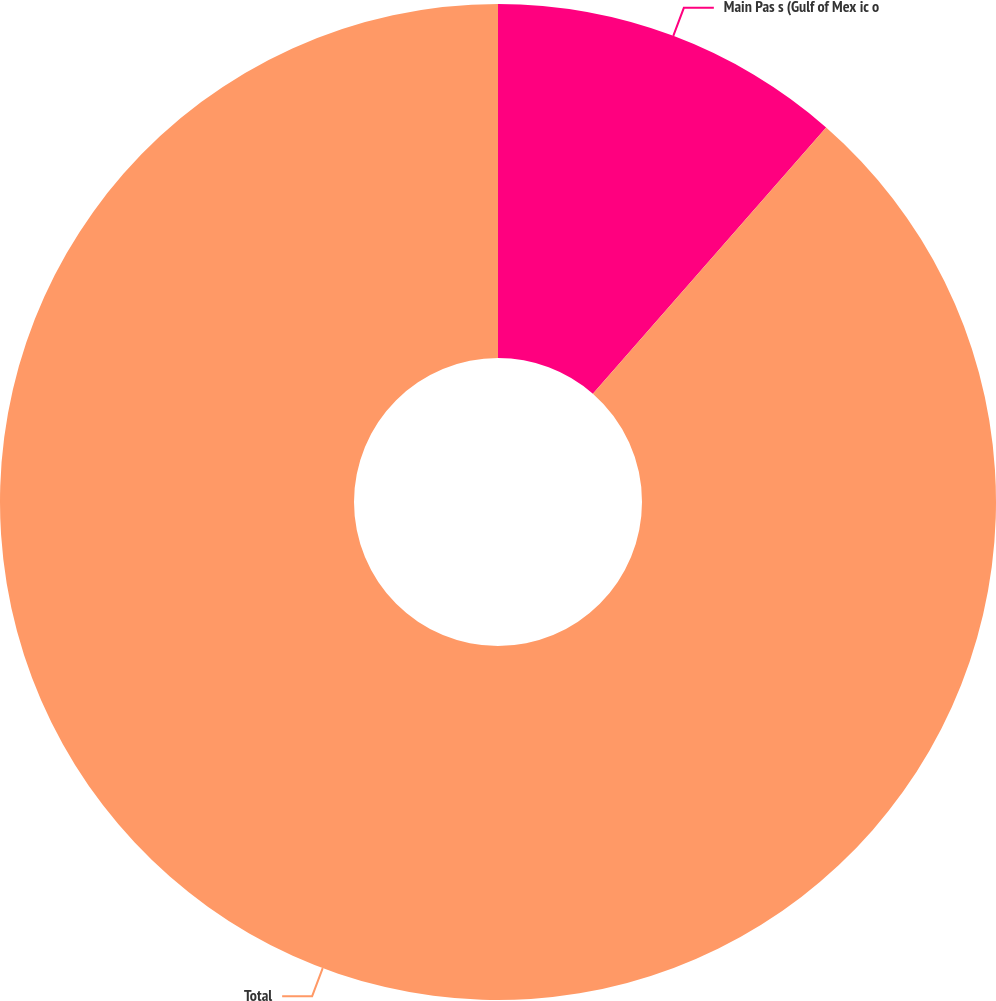Convert chart to OTSL. <chart><loc_0><loc_0><loc_500><loc_500><pie_chart><fcel>Main Pas s (Gulf of Mex ic o<fcel>Total<nl><fcel>11.45%<fcel>88.55%<nl></chart> 